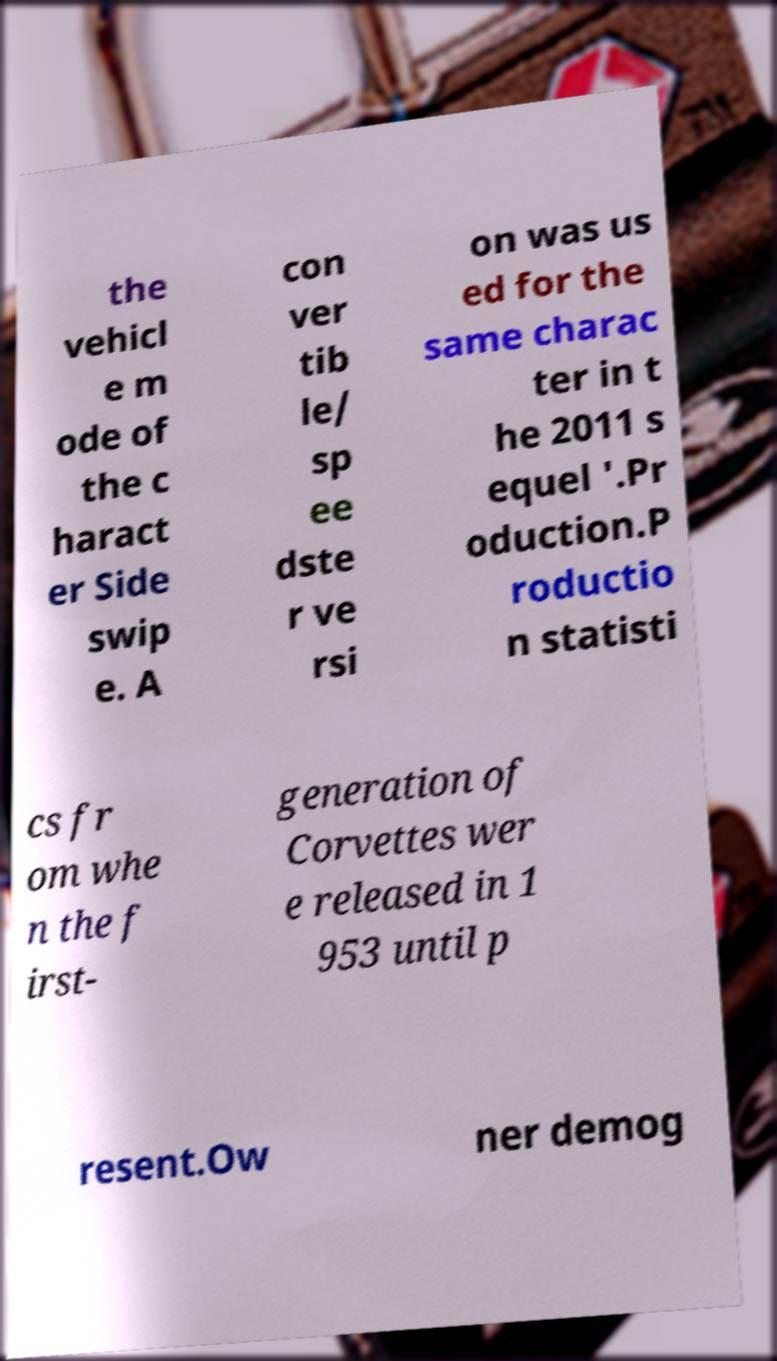Can you accurately transcribe the text from the provided image for me? the vehicl e m ode of the c haract er Side swip e. A con ver tib le/ sp ee dste r ve rsi on was us ed for the same charac ter in t he 2011 s equel '.Pr oduction.P roductio n statisti cs fr om whe n the f irst- generation of Corvettes wer e released in 1 953 until p resent.Ow ner demog 